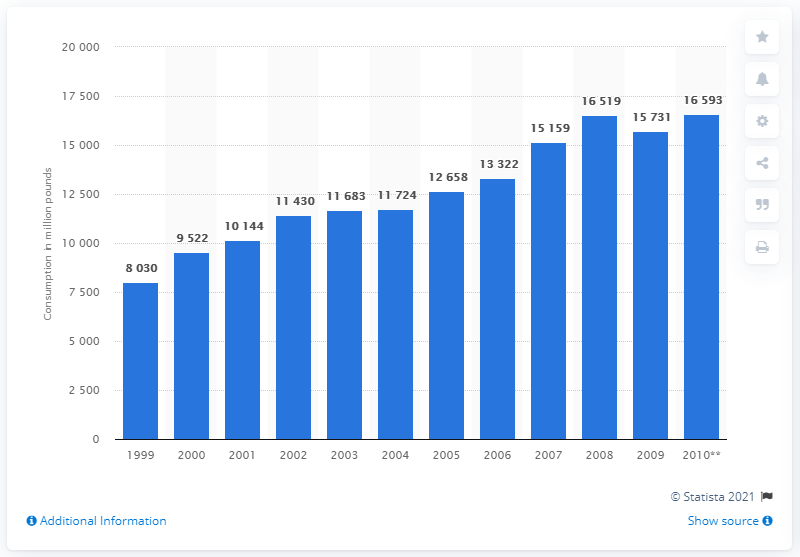Indicate a few pertinent items in this graphic. In 1999, the United States consumed approximately 8,030 metric tons of salad and cooking oil. 